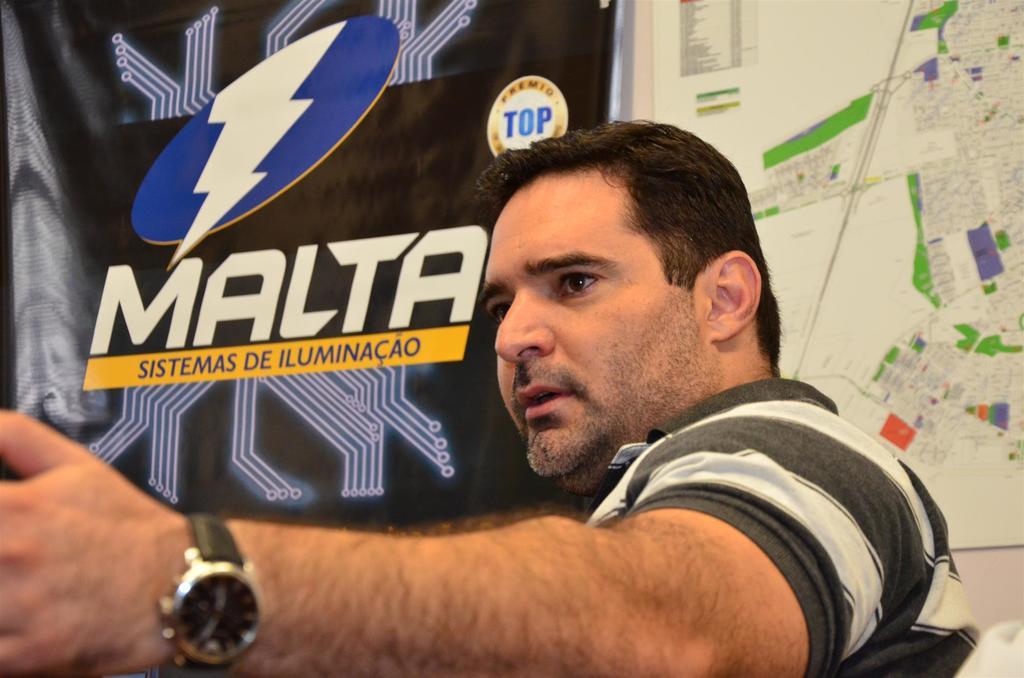What is the brand name on the wall?
Your answer should be very brief. Malta. In what language is the yellow  sing?
Your response must be concise. Spanish. 